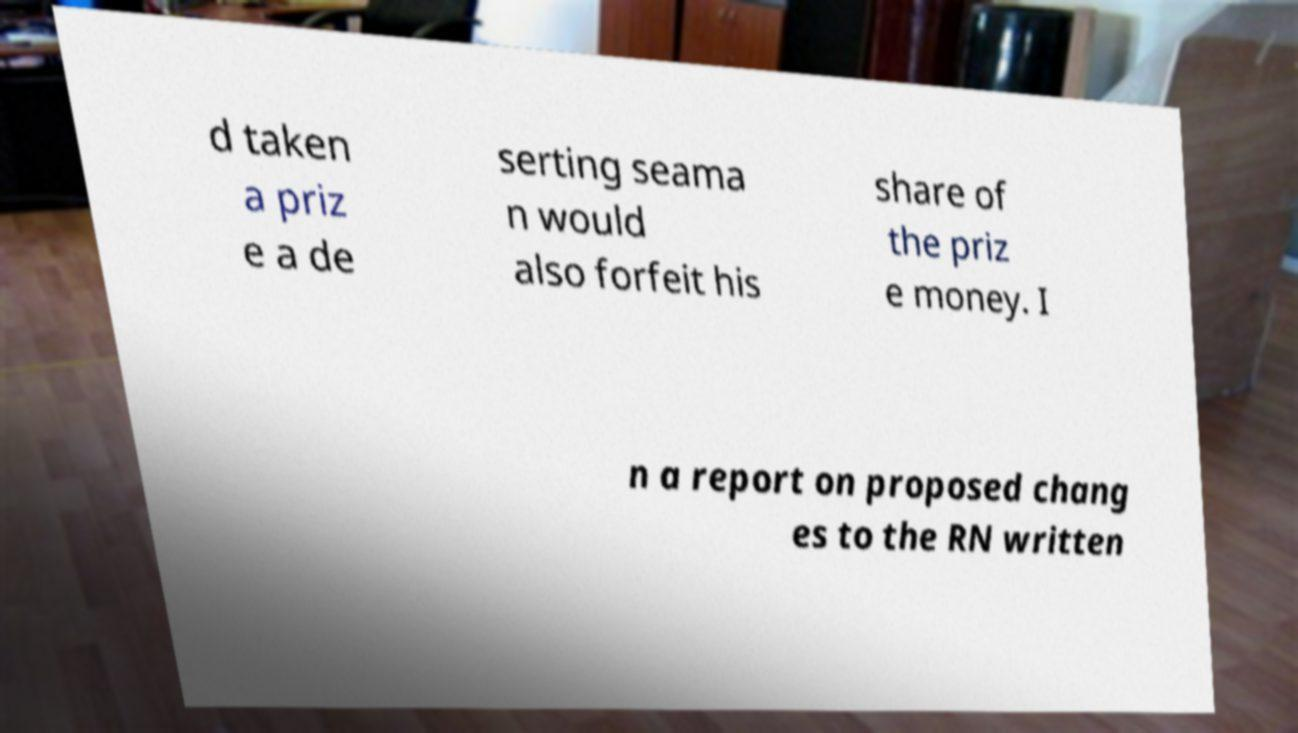Can you read and provide the text displayed in the image?This photo seems to have some interesting text. Can you extract and type it out for me? d taken a priz e a de serting seama n would also forfeit his share of the priz e money. I n a report on proposed chang es to the RN written 